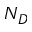<formula> <loc_0><loc_0><loc_500><loc_500>N _ { D }</formula> 